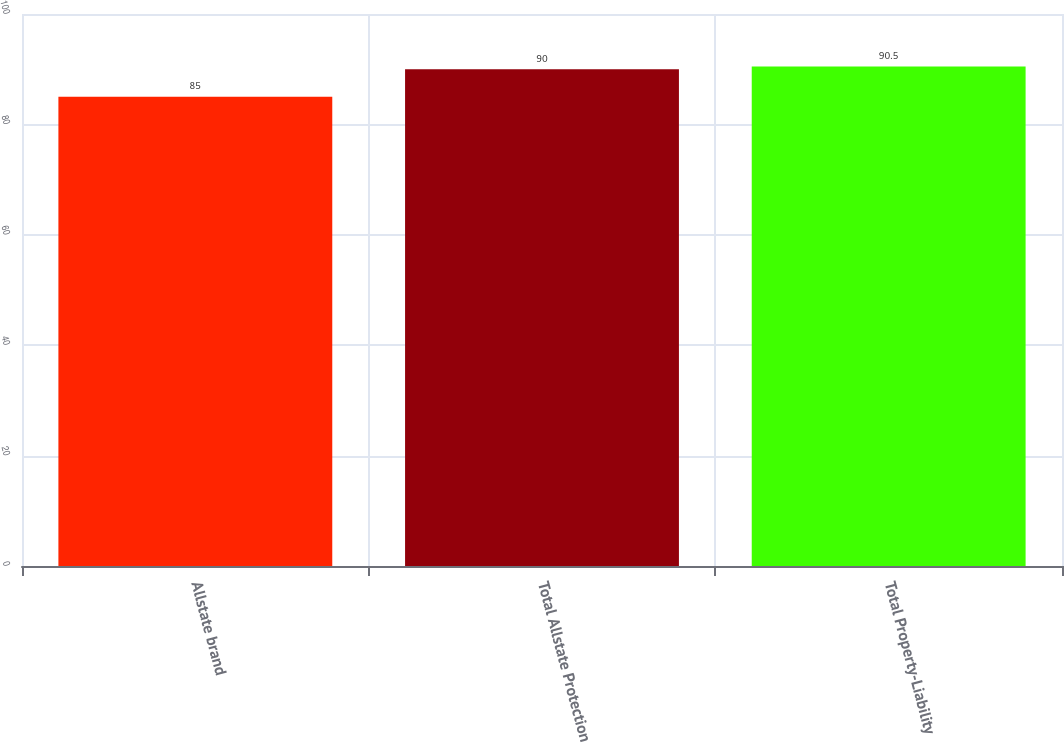Convert chart. <chart><loc_0><loc_0><loc_500><loc_500><bar_chart><fcel>Allstate brand<fcel>Total Allstate Protection<fcel>Total Property-Liability<nl><fcel>85<fcel>90<fcel>90.5<nl></chart> 